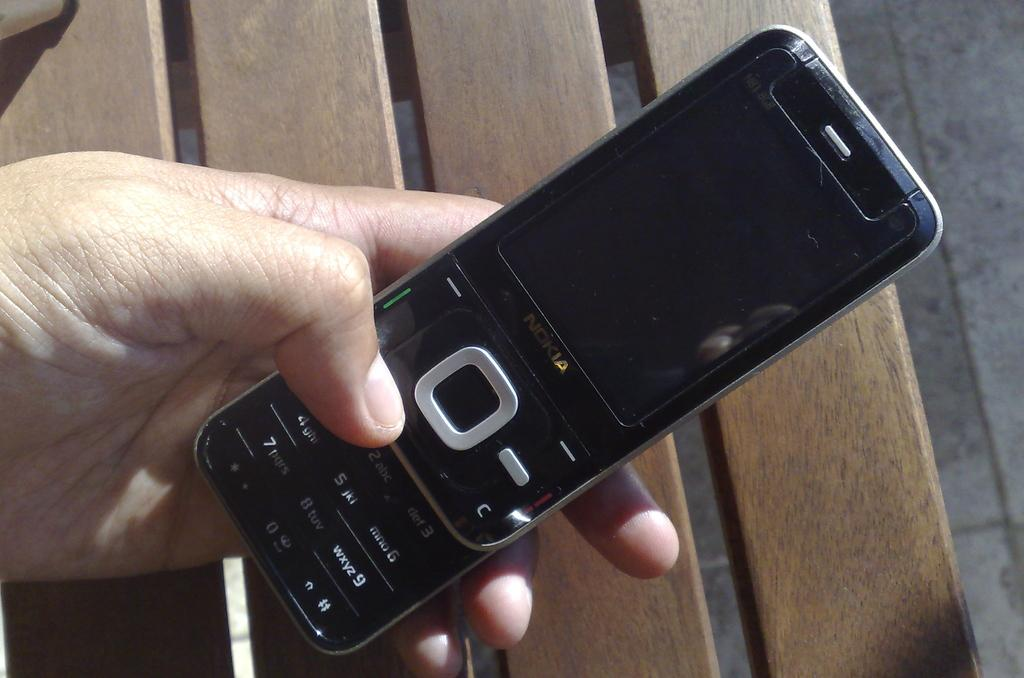<image>
Write a terse but informative summary of the picture. A man holds his black Nokia phone over a bench. 